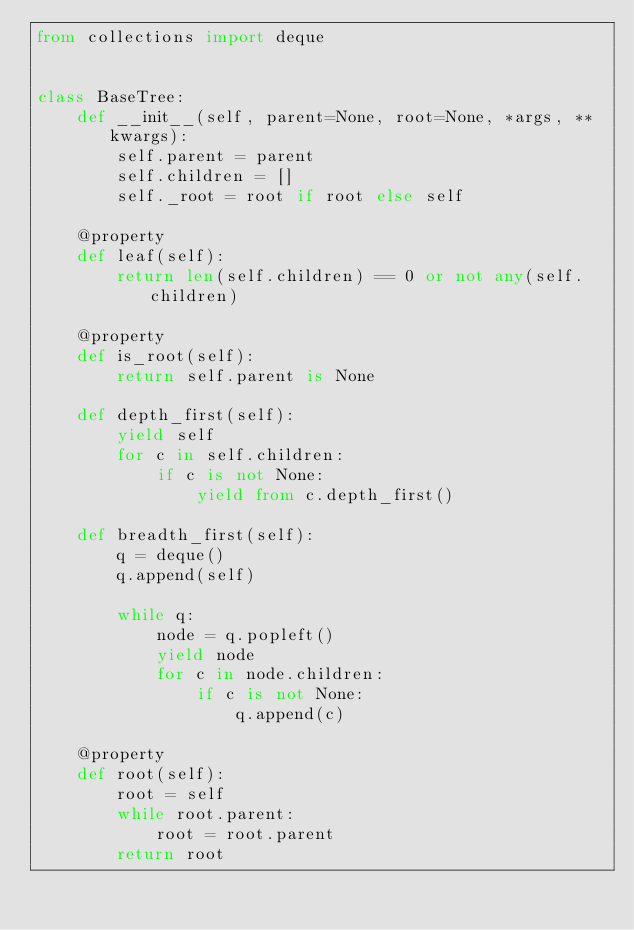Convert code to text. <code><loc_0><loc_0><loc_500><loc_500><_Python_>from collections import deque


class BaseTree:
    def __init__(self, parent=None, root=None, *args, **kwargs):
        self.parent = parent
        self.children = []
        self._root = root if root else self

    @property
    def leaf(self):
        return len(self.children) == 0 or not any(self.children)

    @property
    def is_root(self):
        return self.parent is None

    def depth_first(self):
        yield self
        for c in self.children:
            if c is not None:
                yield from c.depth_first()

    def breadth_first(self):
        q = deque()
        q.append(self)

        while q:
            node = q.popleft()
            yield node
            for c in node.children:
                if c is not None:
                    q.append(c)

    @property
    def root(self):
        root = self
        while root.parent:
            root = root.parent
        return root
</code> 